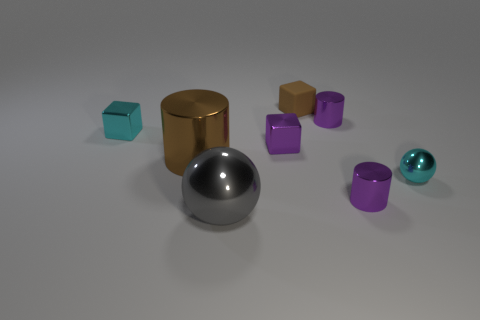How many large yellow matte cubes are there?
Your response must be concise. 0. Is there a brown cylinder of the same size as the matte cube?
Give a very brief answer. No. Are the brown block and the cyan object that is on the left side of the brown rubber thing made of the same material?
Your response must be concise. No. What is the brown object behind the brown metal cylinder made of?
Your answer should be compact. Rubber. How big is the brown metal thing?
Provide a short and direct response. Large. Do the shiny sphere to the right of the rubber thing and the metallic ball that is left of the purple shiny block have the same size?
Your answer should be very brief. No. Does the gray object have the same size as the metallic ball on the right side of the tiny brown rubber cube?
Keep it short and to the point. No. Is there a small shiny cylinder in front of the small purple metallic cylinder that is behind the big cylinder?
Offer a terse response. Yes. The small purple thing in front of the small shiny sphere has what shape?
Offer a very short reply. Cylinder. There is a small thing that is the same color as the big cylinder; what is it made of?
Offer a very short reply. Rubber. 